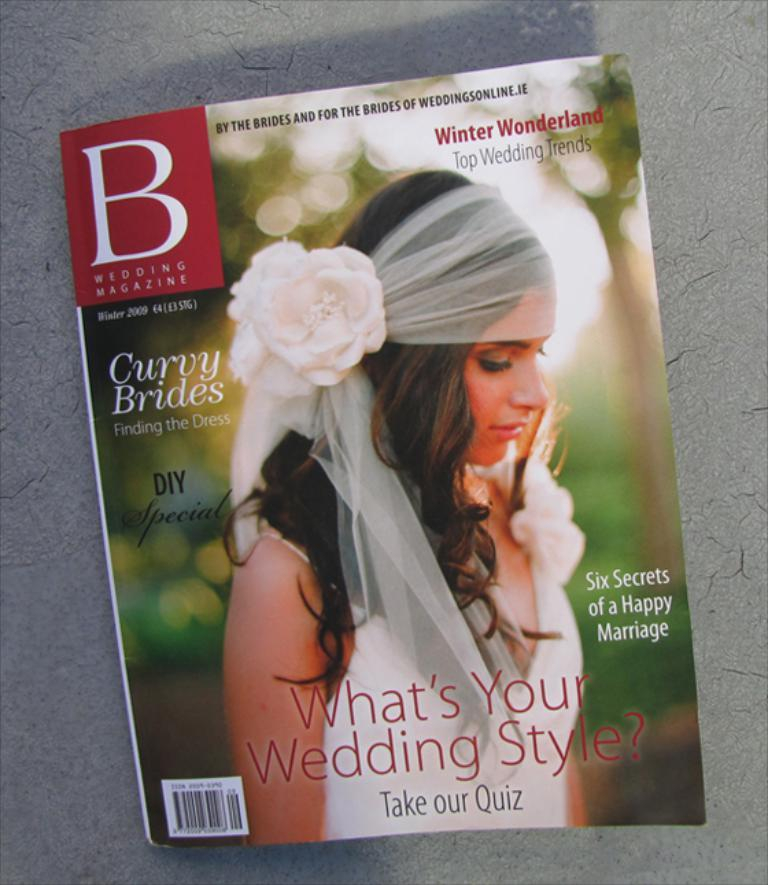What is the main object in the image? There is a paper in the image. What is depicted on the paper? A person wearing a white dress is depicted on the paper. Are there any words or text on the paper? Yes, there is writing on the paper. What color is the floor in the image? The floor is gray in color. How many bears can be seen playing with the kettle in the image? There are no bears or kettle present in the image. What type of beast is depicted on the paper? The image does not depict a beast; it shows a person wearing a white dress. 